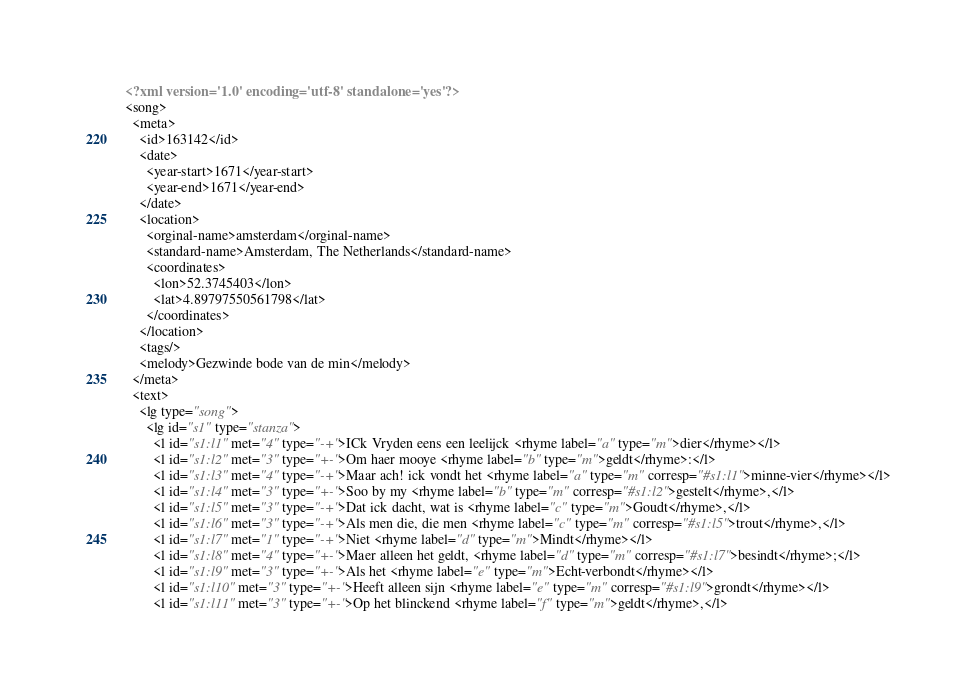<code> <loc_0><loc_0><loc_500><loc_500><_XML_><?xml version='1.0' encoding='utf-8' standalone='yes'?>
<song>
  <meta>
    <id>163142</id>
    <date>
      <year-start>1671</year-start>
      <year-end>1671</year-end>
    </date>
    <location>
      <orginal-name>amsterdam</orginal-name>
      <standard-name>Amsterdam, The Netherlands</standard-name>
      <coordinates>
        <lon>52.3745403</lon>
        <lat>4.89797550561798</lat>
      </coordinates>
    </location>
    <tags/>
    <melody>Gezwinde bode van de min</melody>
  </meta>
  <text>
    <lg type="song">
      <lg id="s1" type="stanza">
        <l id="s1:l1" met="4" type="-+">ICk Vryden eens een leelijck <rhyme label="a" type="m">dier</rhyme></l>
        <l id="s1:l2" met="3" type="+-">Om haer mooye <rhyme label="b" type="m">geldt</rhyme>:</l>
        <l id="s1:l3" met="4" type="-+">Maar ach! ick vondt het <rhyme label="a" type="m" corresp="#s1:l1">minne-vier</rhyme></l>
        <l id="s1:l4" met="3" type="+-">Soo by my <rhyme label="b" type="m" corresp="#s1:l2">gestelt</rhyme>,</l>
        <l id="s1:l5" met="3" type="-+">Dat ick dacht, wat is <rhyme label="c" type="m">Goudt</rhyme>,</l>
        <l id="s1:l6" met="3" type="-+">Als men die, die men <rhyme label="c" type="m" corresp="#s1:l5">trout</rhyme>,</l>
        <l id="s1:l7" met="1" type="-+">Niet <rhyme label="d" type="m">Mindt</rhyme></l>
        <l id="s1:l8" met="4" type="+-">Maer alleen het geldt, <rhyme label="d" type="m" corresp="#s1:l7">besindt</rhyme>;</l>
        <l id="s1:l9" met="3" type="+-">Als het <rhyme label="e" type="m">Echt-verbondt</rhyme></l>
        <l id="s1:l10" met="3" type="+-">Heeft alleen sijn <rhyme label="e" type="m" corresp="#s1:l9">grondt</rhyme></l>
        <l id="s1:l11" met="3" type="+-">Op het blinckend <rhyme label="f" type="m">geldt</rhyme>,</l></code> 